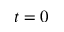Convert formula to latex. <formula><loc_0><loc_0><loc_500><loc_500>t = 0</formula> 